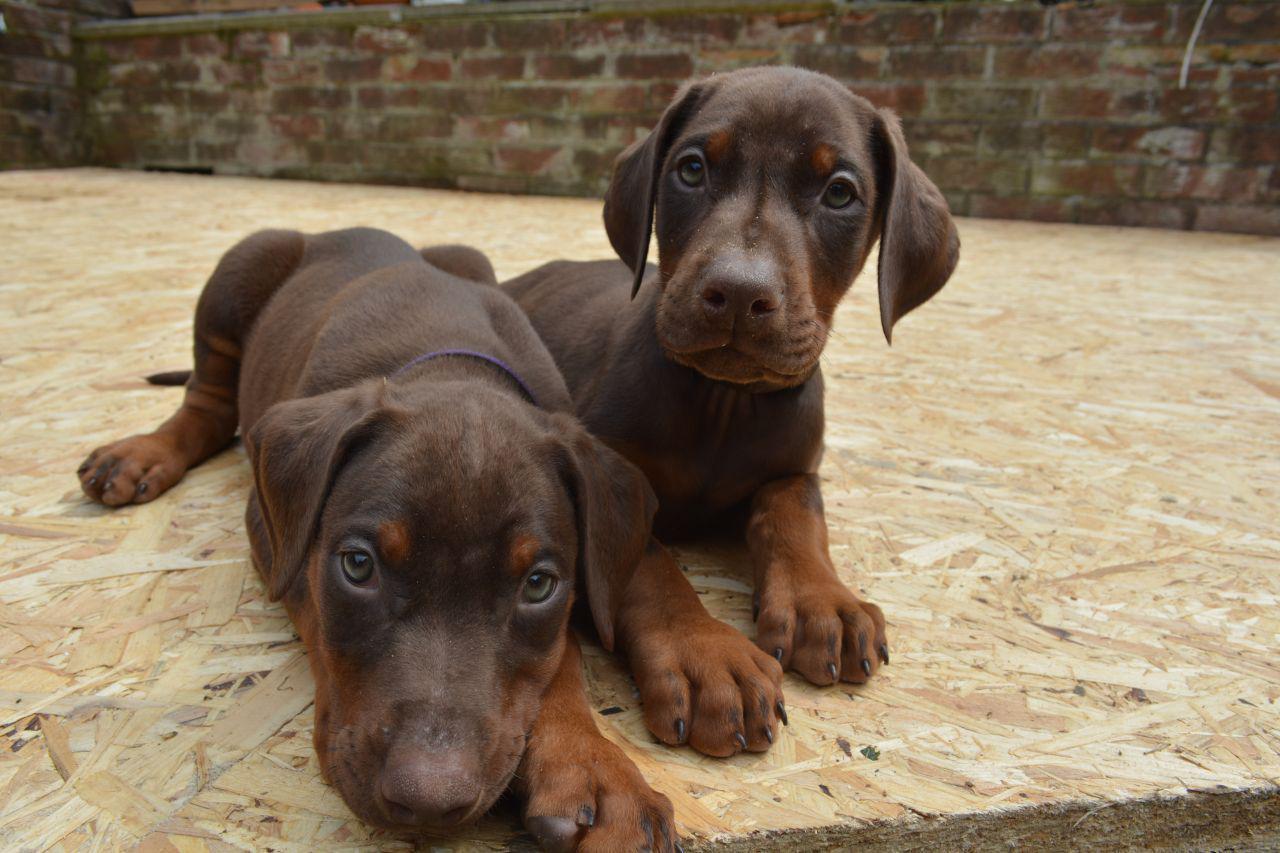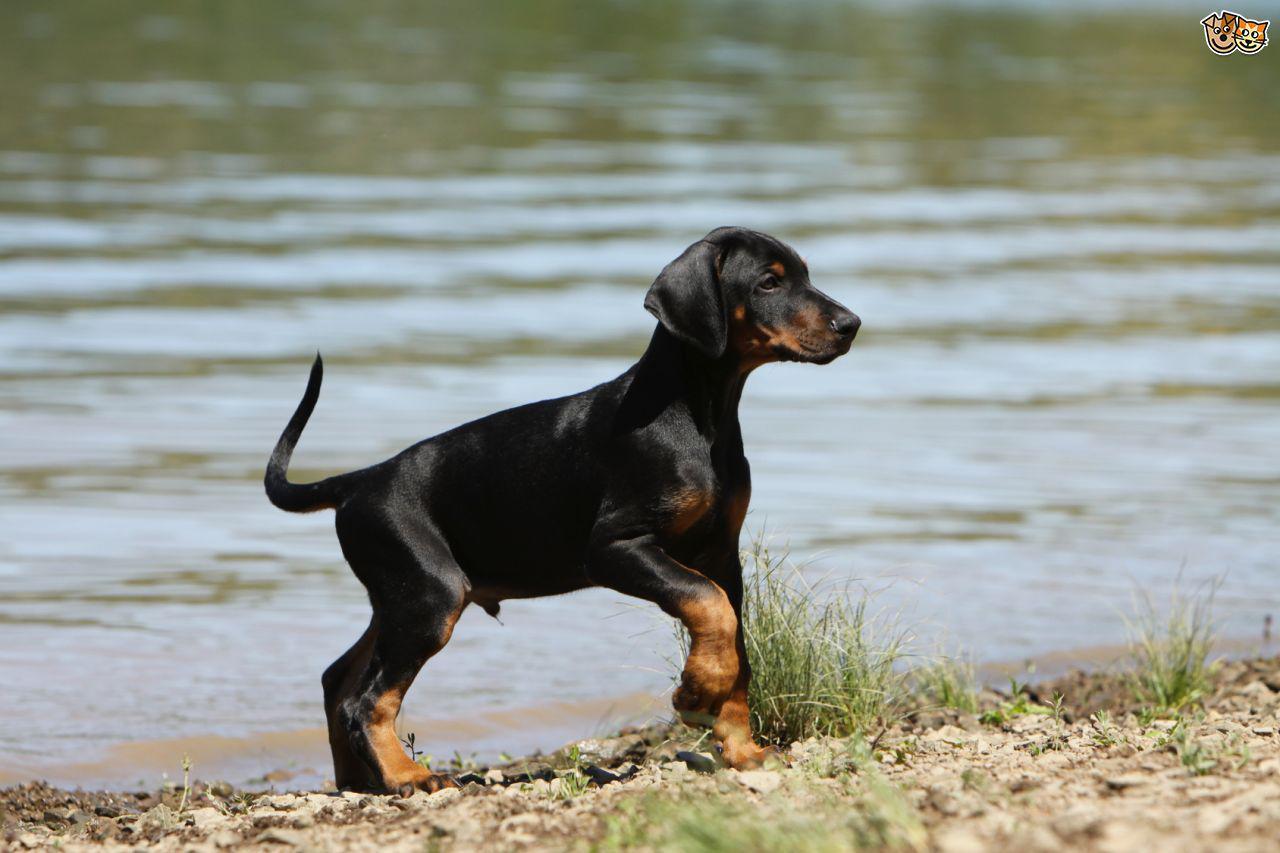The first image is the image on the left, the second image is the image on the right. Analyze the images presented: Is the assertion "Two dogs are sitting in the grass in the image on the right." valid? Answer yes or no. No. The first image is the image on the left, the second image is the image on the right. Evaluate the accuracy of this statement regarding the images: "Two doberman with erect, pointy ears are facing forward and posed side-by-side in the right image.". Is it true? Answer yes or no. No. 